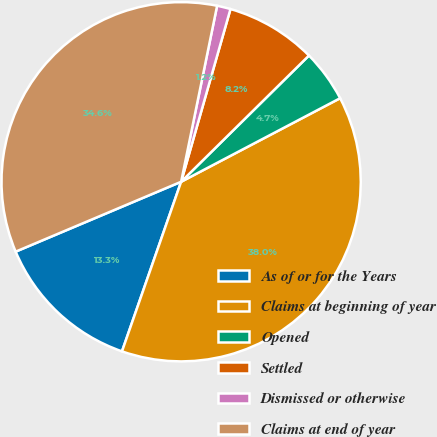<chart> <loc_0><loc_0><loc_500><loc_500><pie_chart><fcel>As of or for the Years<fcel>Claims at beginning of year<fcel>Opened<fcel>Settled<fcel>Dismissed or otherwise<fcel>Claims at end of year<nl><fcel>13.3%<fcel>38.04%<fcel>4.7%<fcel>8.17%<fcel>1.22%<fcel>34.57%<nl></chart> 